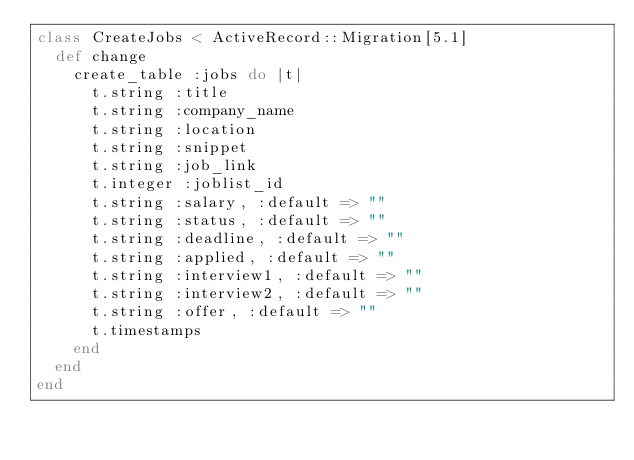<code> <loc_0><loc_0><loc_500><loc_500><_Ruby_>class CreateJobs < ActiveRecord::Migration[5.1]
  def change
    create_table :jobs do |t|
      t.string :title
      t.string :company_name
      t.string :location
      t.string :snippet
      t.string :job_link
      t.integer :joblist_id
      t.string :salary, :default => ""
      t.string :status, :default => ""
      t.string :deadline, :default => ""
      t.string :applied, :default => ""
      t.string :interview1, :default => ""
      t.string :interview2, :default => ""
      t.string :offer, :default => ""
      t.timestamps
    end
  end
end
</code> 